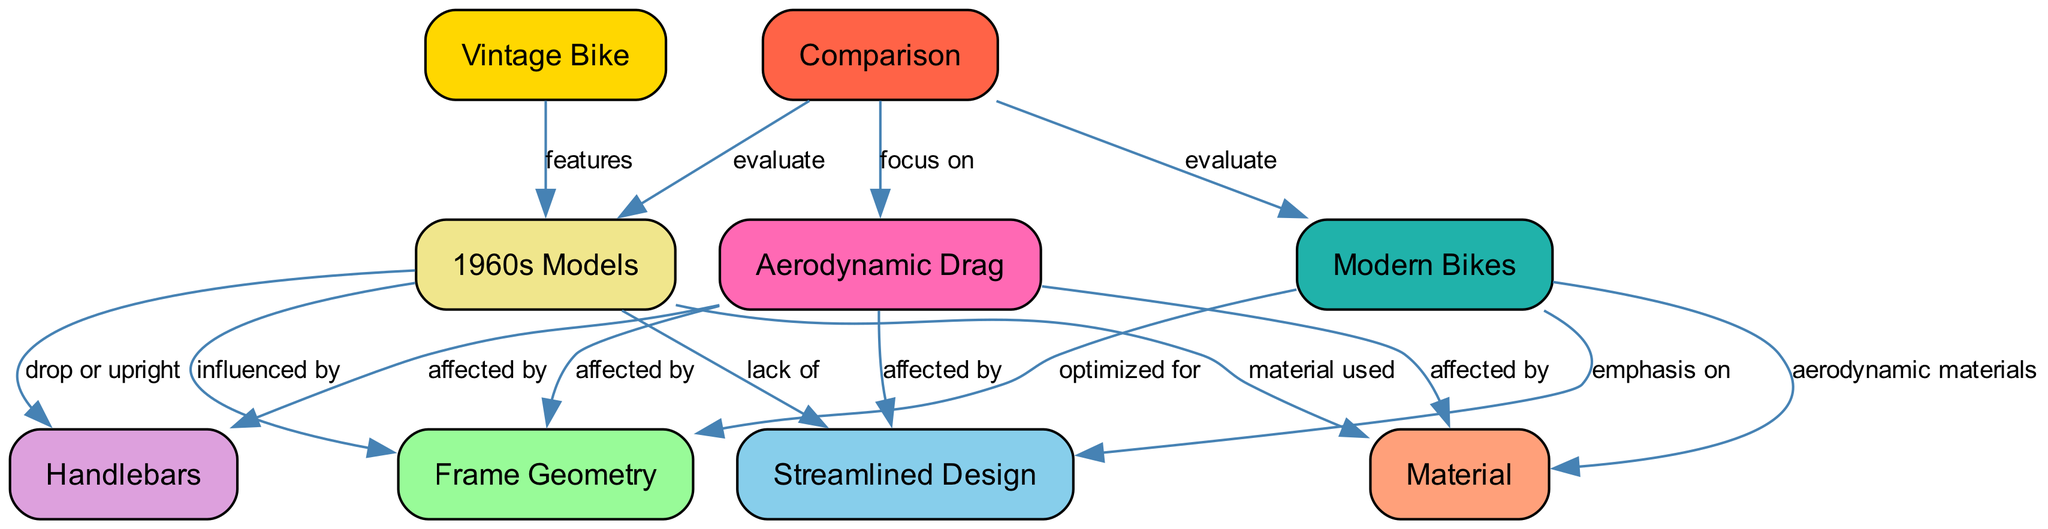What is the primary focus of the comparison in the diagram? The diagram indicates that the comparison focuses on "Aerodynamic Drag" as it is explicitly linked to the "Comparison" node.
Answer: Aerodynamic Drag How many total nodes are present in the diagram? By counting the nodes listed, there are a total of nine nodes present in the diagram.
Answer: 9 Which design aspect is emphasized in modern bikes according to the diagram? The diagram shows that "Streamlined Design" is emphasized in "Modern Bikes," highlighting a key difference from vintage models.
Answer: Streamlined Design What relationship do 1960s models have with frame geometry? The diagram establishes that "1960s Models" are influenced by "Frame Geometry,” indicating a direct connection in their design aspects.
Answer: influenced by Which node is affected by handlebars in the diagram? According to the diagram, the node "Aerodynamic Drag" is affected by "Handlebars," showing how design choices impact aerodynamics.
Answer: Aerodynamic Drag What is the material characteristic of modern bikes shown in the diagram? The diagram indicates that "Modern Bikes" use "aerodynamic materials," which are designed to reduce drag and enhance efficiency.
Answer: aerodynamic materials Which element is lacking in the 1960s models as per the diagram? The diagram states that 1960s models have a "lack of Streamlined Design," indicating a deficiency in aerodynamic features compared to modern counterparts.
Answer: lack of Streamlined Design What design elements do the 1960s models use as described in the diagram? The diagram specifies that 1960s models utilize "drop or upright" handlebars, which influences their overall design according to the diagram.
Answer: drop or upright Which node is associated with the evaluation of both vintage and modern bikes? The "Comparison" node in the diagram links both types of bikes for evaluation, reflecting a comparative study on their aerodynamic efficiency.
Answer: Comparison 